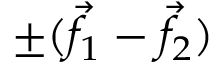Convert formula to latex. <formula><loc_0><loc_0><loc_500><loc_500>\pm ( { \vec { f } } _ { 1 } - { \vec { f } } _ { 2 } )</formula> 